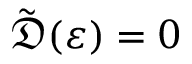Convert formula to latex. <formula><loc_0><loc_0><loc_500><loc_500>\tilde { \mathfrak { D } } ( \varepsilon ) = 0</formula> 